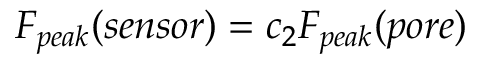<formula> <loc_0><loc_0><loc_500><loc_500>F _ { p e a k } ( s e n s o r ) = c _ { 2 } F _ { p e a k } ( p o r e )</formula> 